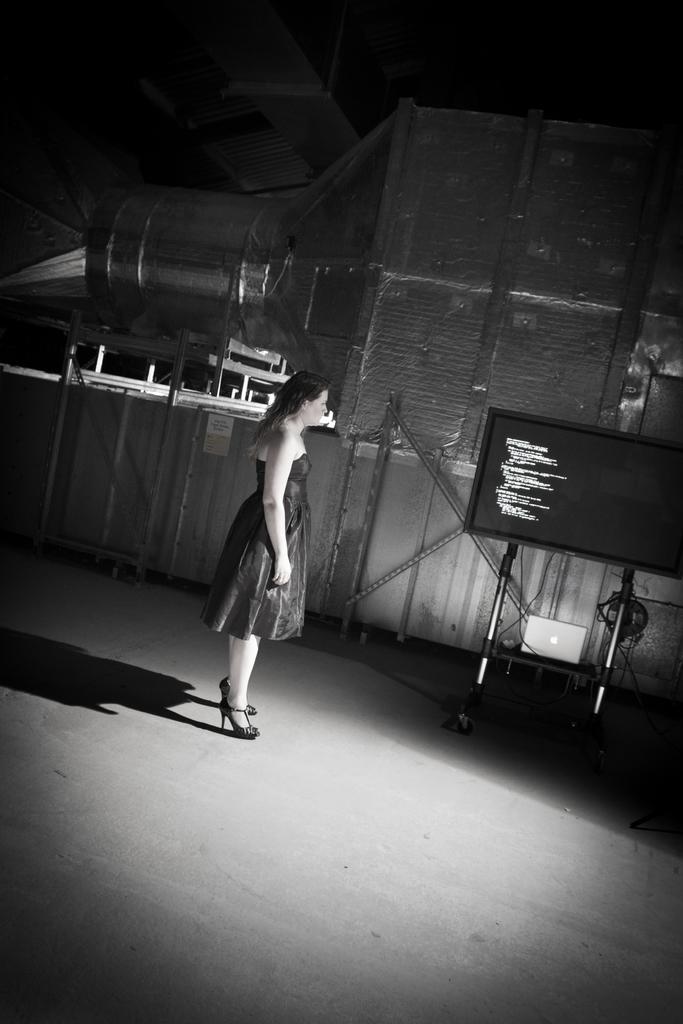In one or two sentences, can you explain what this image depicts? Here in this picture we can see a woman standing on the floor over there and on the right side we can see a monitor screen present on a stand over there and beside her also we can see other things present over there. 